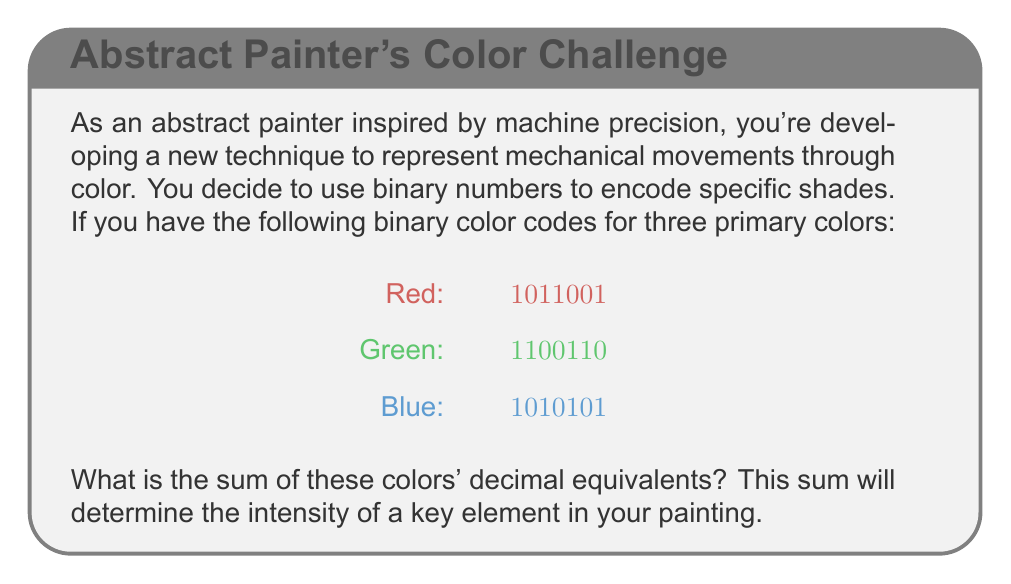Show me your answer to this math problem. To solve this problem, we need to convert each binary number to its decimal equivalent and then sum the results. Let's go through this step-by-step:

1. Converting Red ($$1011001$$) to decimal:
   $$1\cdot2^6 + 0\cdot2^5 + 1\cdot2^4 + 1\cdot2^3 + 0\cdot2^2 + 0\cdot2^1 + 1\cdot2^0$$
   $$= 64 + 0 + 16 + 8 + 0 + 0 + 1 = 89$$

2. Converting Green ($$1100110$$) to decimal:
   $$1\cdot2^6 + 1\cdot2^5 + 0\cdot2^4 + 0\cdot2^3 + 1\cdot2^2 + 1\cdot2^1 + 0\cdot2^0$$
   $$= 64 + 32 + 0 + 0 + 4 + 2 + 0 = 102$$

3. Converting Blue ($$1010101$$) to decimal:
   $$1\cdot2^6 + 0\cdot2^5 + 1\cdot2^4 + 0\cdot2^3 + 1\cdot2^2 + 0\cdot2^1 + 1\cdot2^0$$
   $$= 64 + 0 + 16 + 0 + 4 + 0 + 1 = 85$$

4. Sum the decimal equivalents:
   $$89 + 102 + 85 = 276$$

Therefore, the sum of the decimal equivalents is 276.
Answer: 276 